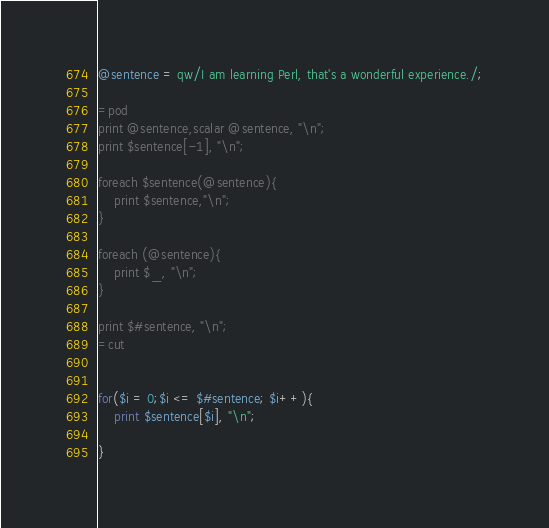Convert code to text. <code><loc_0><loc_0><loc_500><loc_500><_Perl_>@sentence = qw/I am learning Perl, that's a wonderful experience./;

=pod
print @sentence,scalar @sentence, "\n";
print $sentence[-1], "\n";

foreach $sentence(@sentence){
    print $sentence,"\n";
}

foreach (@sentence){
    print $_, "\n";
}

print $#sentence, "\n";
=cut


for($i = 0;$i <= $#sentence; $i++){
    print $sentence[$i], "\n";

}

</code> 